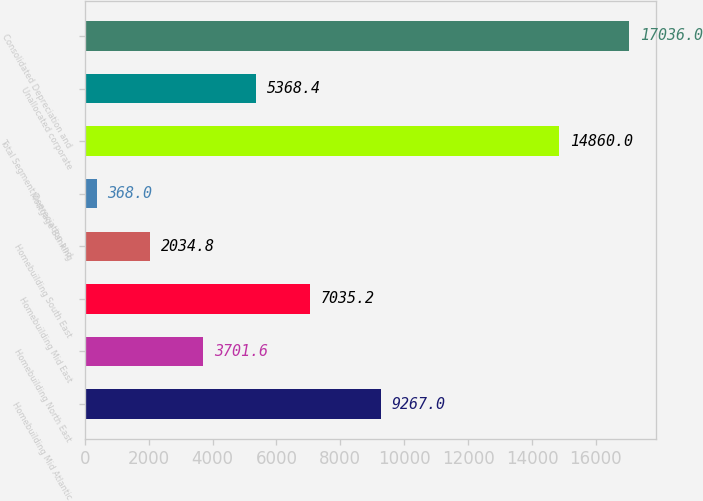Convert chart to OTSL. <chart><loc_0><loc_0><loc_500><loc_500><bar_chart><fcel>Homebuilding Mid Atlantic<fcel>Homebuilding North East<fcel>Homebuilding Mid East<fcel>Homebuilding South East<fcel>Mortgage Banking<fcel>Total Segment Depreciation and<fcel>Unallocated corporate<fcel>Consolidated Depreciation and<nl><fcel>9267<fcel>3701.6<fcel>7035.2<fcel>2034.8<fcel>368<fcel>14860<fcel>5368.4<fcel>17036<nl></chart> 